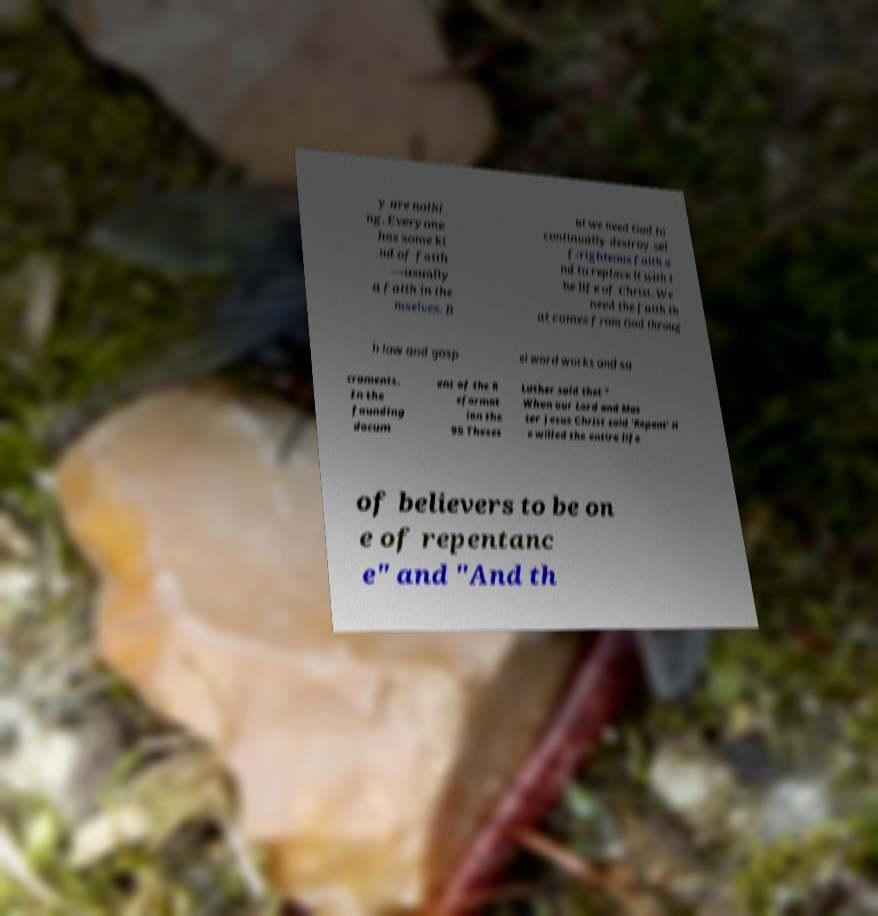I need the written content from this picture converted into text. Can you do that? y are nothi ng. Everyone has some ki nd of faith —usually a faith in the mselves. B ut we need God to continually destroy sel f-righteous faith a nd to replace it with t he life of Christ. We need the faith th at comes from God throug h law and gosp el word works and sa craments. In the founding docum ent of the R eformat ion the 95 Theses Luther said that " When our Lord and Mas ter Jesus Christ said 'Repent' H e willed the entire life of believers to be on e of repentanc e" and "And th 